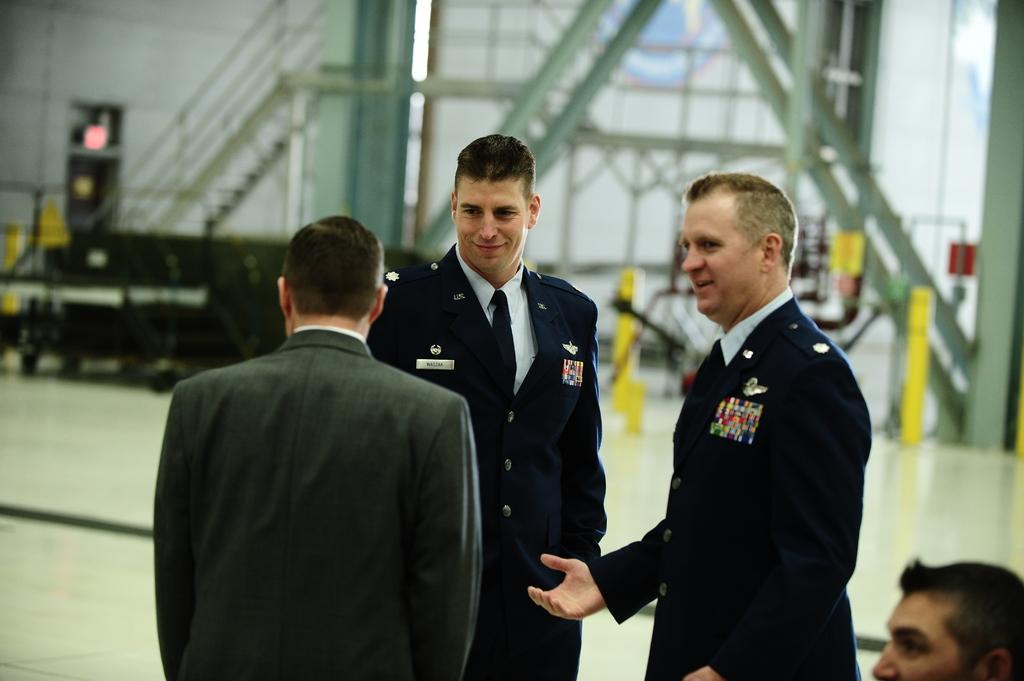What is the primary subject of the image? There are men standing in the image. Can you describe the iron structure in the image? Yes, there is an iron structure in the image. What type of silver channel can be seen connecting the men in the image? There is no silver channel connecting the men in the image; it only features men standing and an iron structure. 